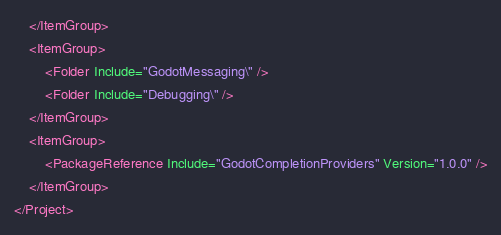Convert code to text. <code><loc_0><loc_0><loc_500><loc_500><_XML_>    </ItemGroup>
    <ItemGroup>
        <Folder Include="GodotMessaging\" />
        <Folder Include="Debugging\" />
    </ItemGroup>
    <ItemGroup>
        <PackageReference Include="GodotCompletionProviders" Version="1.0.0" />
    </ItemGroup>
</Project>
</code> 